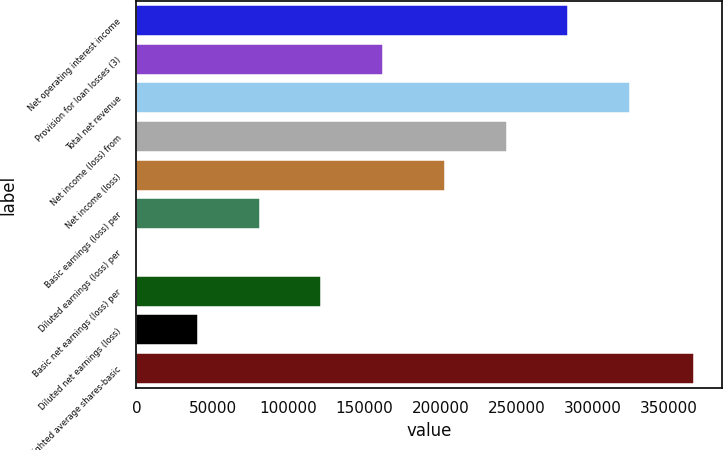Convert chart to OTSL. <chart><loc_0><loc_0><loc_500><loc_500><bar_chart><fcel>Net operating interest income<fcel>Provision for loan losses (3)<fcel>Total net revenue<fcel>Net income (loss) from<fcel>Net income (loss)<fcel>Basic earnings (loss) per<fcel>Diluted earnings (loss) per<fcel>Basic net earnings (loss) per<fcel>Diluted net earnings (loss)<fcel>Weighted average shares-basic<nl><fcel>283773<fcel>162156<fcel>324311<fcel>243234<fcel>202695<fcel>81078.6<fcel>0.99<fcel>121617<fcel>40539.8<fcel>366586<nl></chart> 